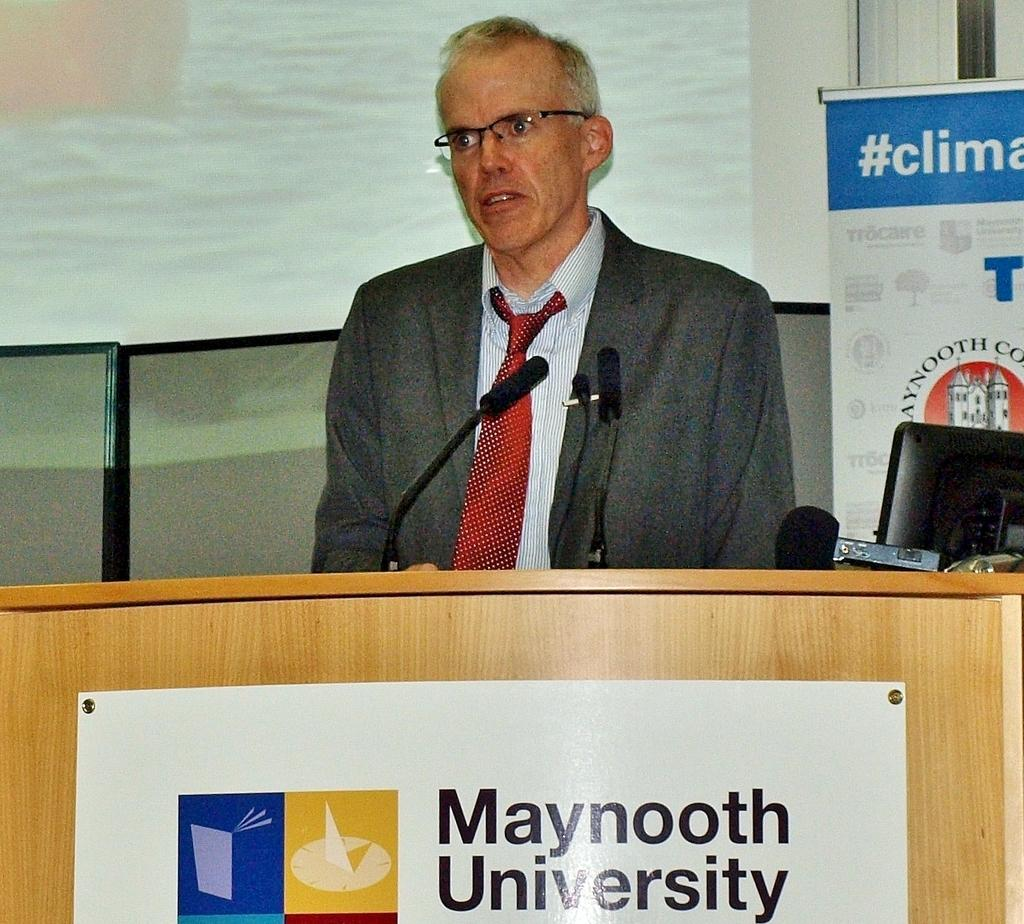Provide a one-sentence caption for the provided image. A man is standing at a podium at Maynooth University. 